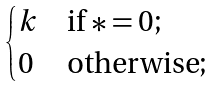Convert formula to latex. <formula><loc_0><loc_0><loc_500><loc_500>\begin{cases} k & \text {if $* = 0$} ; \\ 0 & \text {otherwise} ; \end{cases}</formula> 